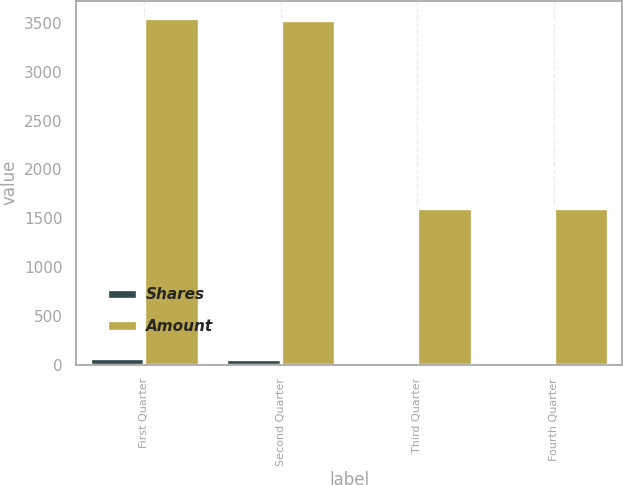<chart> <loc_0><loc_0><loc_500><loc_500><stacked_bar_chart><ecel><fcel>First Quarter<fcel>Second Quarter<fcel>Third Quarter<fcel>Fourth Quarter<nl><fcel>Shares<fcel>63<fcel>59<fcel>25<fcel>23<nl><fcel>Amount<fcel>3550<fcel>3533<fcel>1600<fcel>1600<nl></chart> 